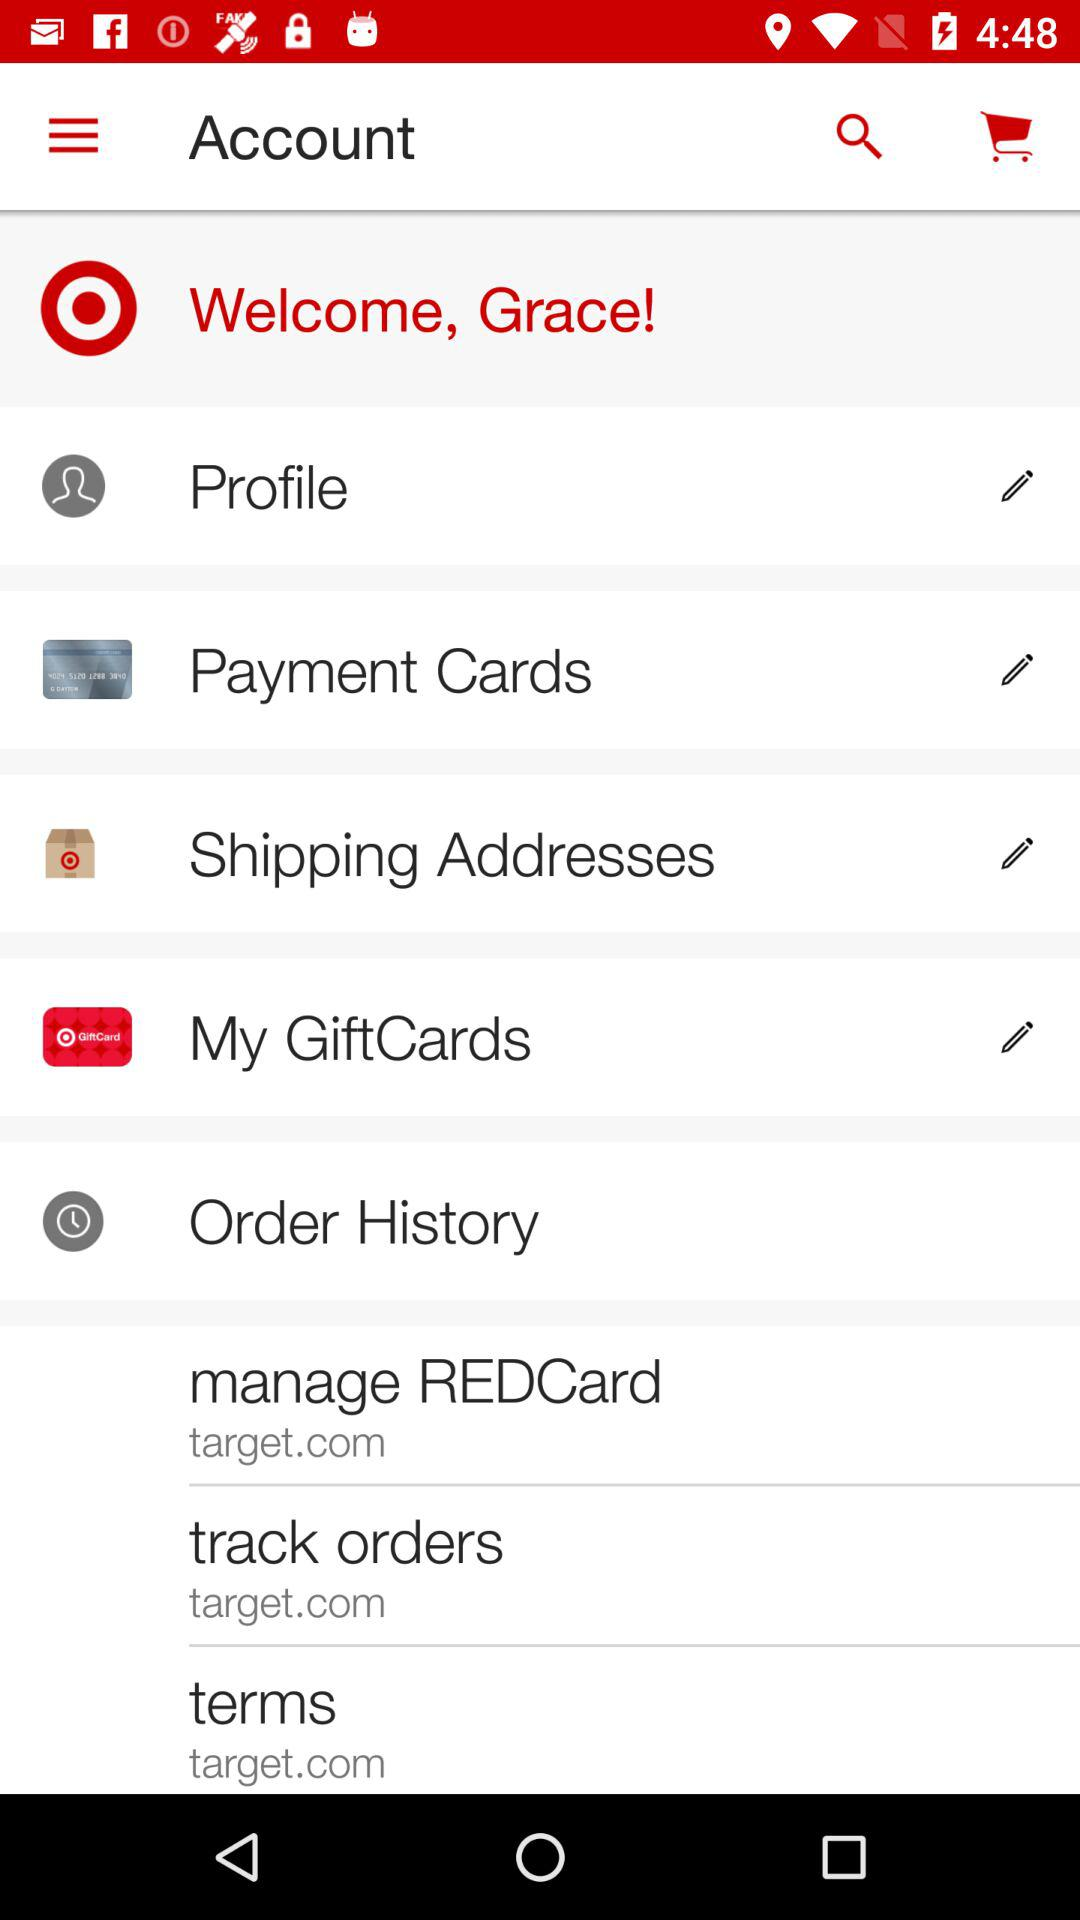What is the name of the user? The name of the user is "Grace". 